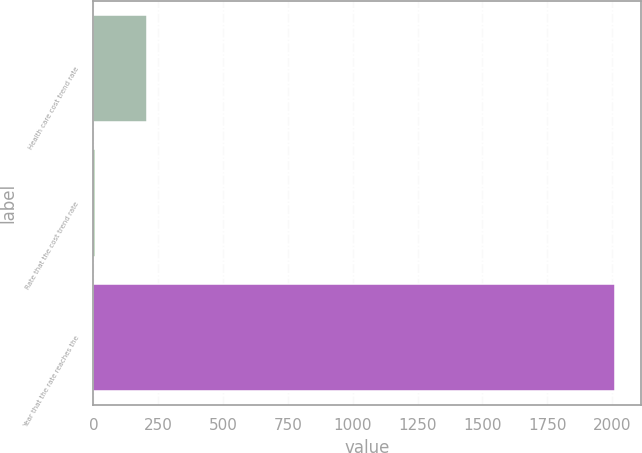<chart> <loc_0><loc_0><loc_500><loc_500><bar_chart><fcel>Health care cost trend rate<fcel>Rate that the cost trend rate<fcel>Year that the rate reaches the<nl><fcel>205.6<fcel>5<fcel>2011<nl></chart> 